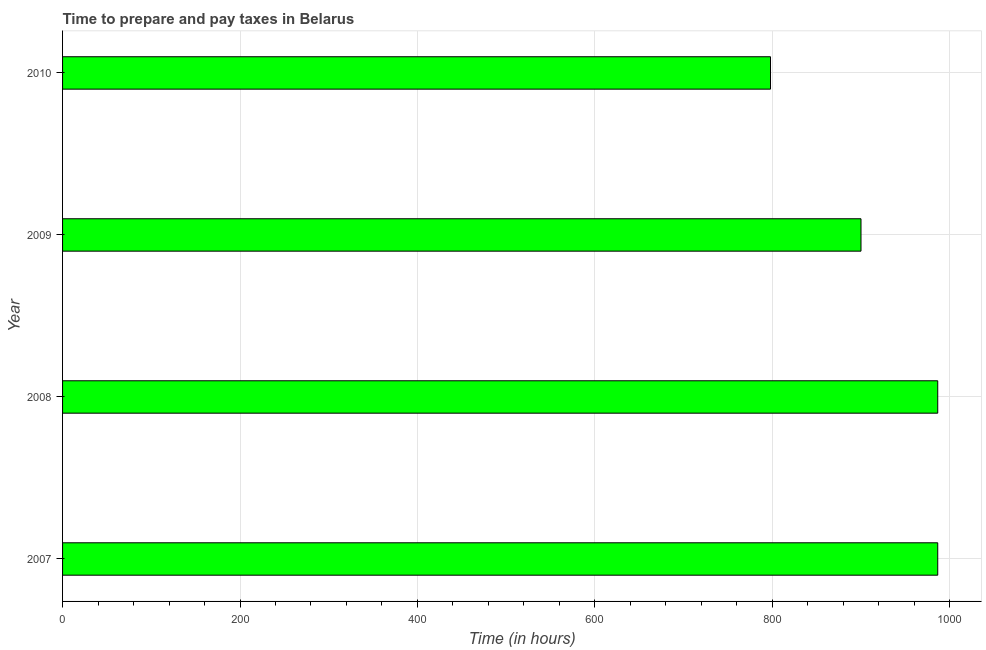Does the graph contain grids?
Ensure brevity in your answer.  Yes. What is the title of the graph?
Your answer should be compact. Time to prepare and pay taxes in Belarus. What is the label or title of the X-axis?
Keep it short and to the point. Time (in hours). What is the time to prepare and pay taxes in 2007?
Provide a succinct answer. 986.5. Across all years, what is the maximum time to prepare and pay taxes?
Offer a terse response. 986.5. Across all years, what is the minimum time to prepare and pay taxes?
Offer a very short reply. 798. In which year was the time to prepare and pay taxes maximum?
Offer a terse response. 2007. In which year was the time to prepare and pay taxes minimum?
Give a very brief answer. 2010. What is the sum of the time to prepare and pay taxes?
Your answer should be very brief. 3671. What is the difference between the time to prepare and pay taxes in 2009 and 2010?
Your answer should be very brief. 102. What is the average time to prepare and pay taxes per year?
Give a very brief answer. 917.75. What is the median time to prepare and pay taxes?
Your response must be concise. 943.25. Do a majority of the years between 2008 and 2010 (inclusive) have time to prepare and pay taxes greater than 80 hours?
Keep it short and to the point. Yes. What is the ratio of the time to prepare and pay taxes in 2008 to that in 2009?
Ensure brevity in your answer.  1.1. Is the time to prepare and pay taxes in 2007 less than that in 2009?
Your answer should be very brief. No. Is the difference between the time to prepare and pay taxes in 2007 and 2009 greater than the difference between any two years?
Your response must be concise. No. Is the sum of the time to prepare and pay taxes in 2007 and 2008 greater than the maximum time to prepare and pay taxes across all years?
Your answer should be compact. Yes. What is the difference between the highest and the lowest time to prepare and pay taxes?
Give a very brief answer. 188.5. How many years are there in the graph?
Provide a succinct answer. 4. What is the difference between two consecutive major ticks on the X-axis?
Ensure brevity in your answer.  200. What is the Time (in hours) of 2007?
Give a very brief answer. 986.5. What is the Time (in hours) of 2008?
Keep it short and to the point. 986.5. What is the Time (in hours) in 2009?
Make the answer very short. 900. What is the Time (in hours) in 2010?
Provide a succinct answer. 798. What is the difference between the Time (in hours) in 2007 and 2009?
Provide a succinct answer. 86.5. What is the difference between the Time (in hours) in 2007 and 2010?
Your response must be concise. 188.5. What is the difference between the Time (in hours) in 2008 and 2009?
Provide a succinct answer. 86.5. What is the difference between the Time (in hours) in 2008 and 2010?
Provide a succinct answer. 188.5. What is the difference between the Time (in hours) in 2009 and 2010?
Your response must be concise. 102. What is the ratio of the Time (in hours) in 2007 to that in 2008?
Your answer should be very brief. 1. What is the ratio of the Time (in hours) in 2007 to that in 2009?
Keep it short and to the point. 1.1. What is the ratio of the Time (in hours) in 2007 to that in 2010?
Provide a succinct answer. 1.24. What is the ratio of the Time (in hours) in 2008 to that in 2009?
Make the answer very short. 1.1. What is the ratio of the Time (in hours) in 2008 to that in 2010?
Keep it short and to the point. 1.24. What is the ratio of the Time (in hours) in 2009 to that in 2010?
Your response must be concise. 1.13. 